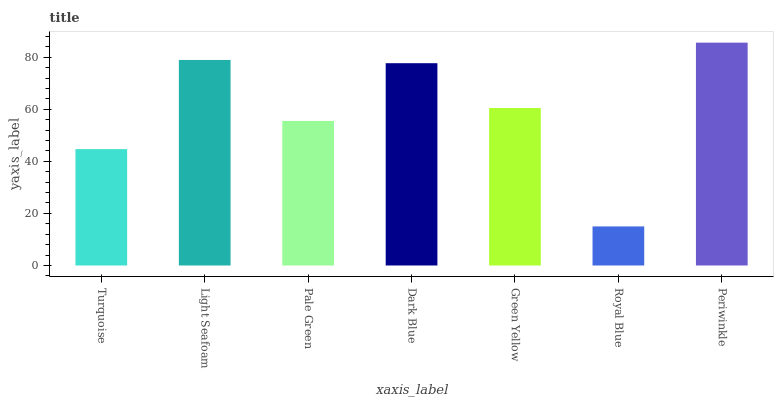Is Royal Blue the minimum?
Answer yes or no. Yes. Is Periwinkle the maximum?
Answer yes or no. Yes. Is Light Seafoam the minimum?
Answer yes or no. No. Is Light Seafoam the maximum?
Answer yes or no. No. Is Light Seafoam greater than Turquoise?
Answer yes or no. Yes. Is Turquoise less than Light Seafoam?
Answer yes or no. Yes. Is Turquoise greater than Light Seafoam?
Answer yes or no. No. Is Light Seafoam less than Turquoise?
Answer yes or no. No. Is Green Yellow the high median?
Answer yes or no. Yes. Is Green Yellow the low median?
Answer yes or no. Yes. Is Periwinkle the high median?
Answer yes or no. No. Is Royal Blue the low median?
Answer yes or no. No. 